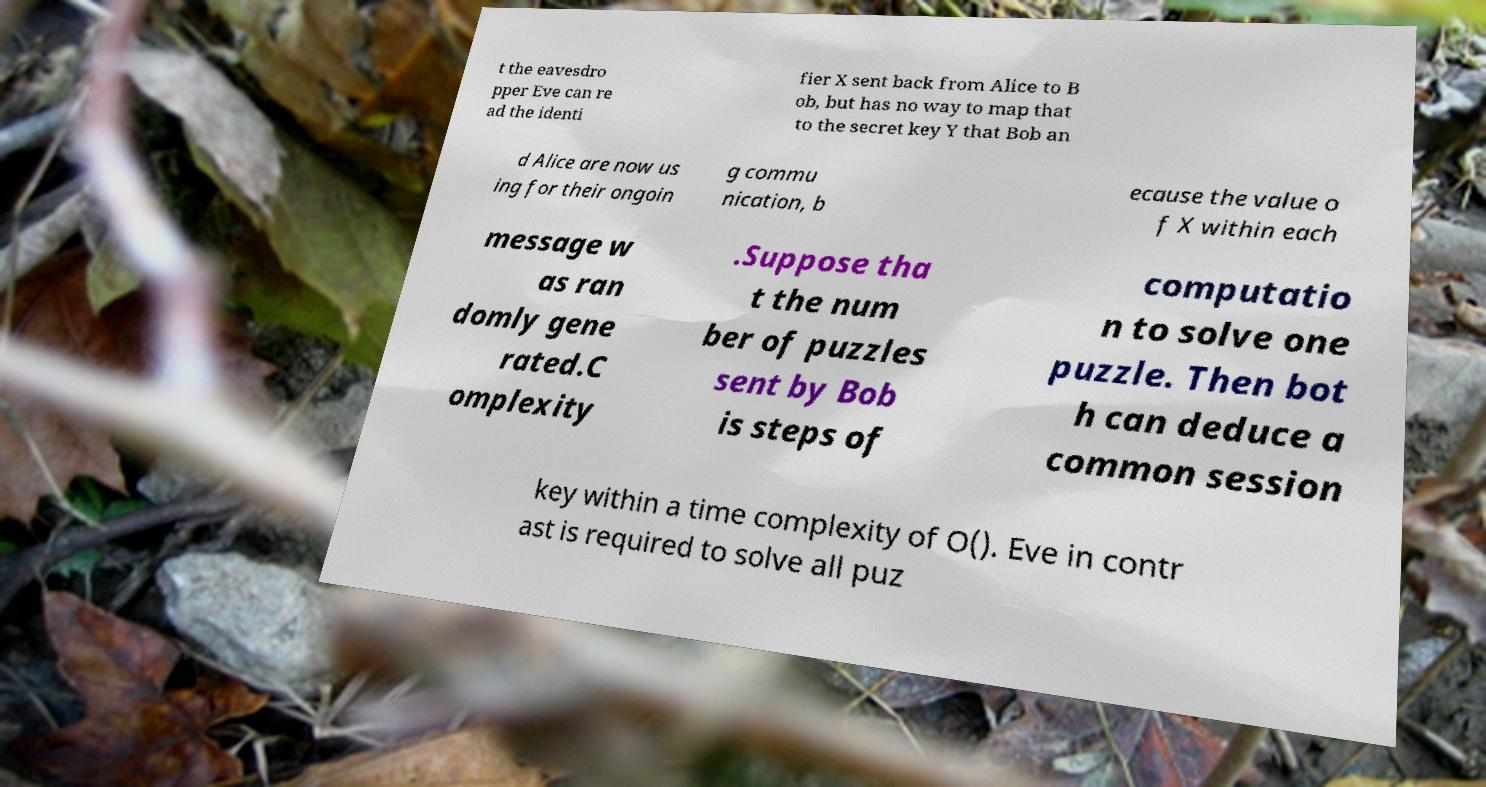Could you assist in decoding the text presented in this image and type it out clearly? t the eavesdro pper Eve can re ad the identi fier X sent back from Alice to B ob, but has no way to map that to the secret key Y that Bob an d Alice are now us ing for their ongoin g commu nication, b ecause the value o f X within each message w as ran domly gene rated.C omplexity .Suppose tha t the num ber of puzzles sent by Bob is steps of computatio n to solve one puzzle. Then bot h can deduce a common session key within a time complexity of O(). Eve in contr ast is required to solve all puz 